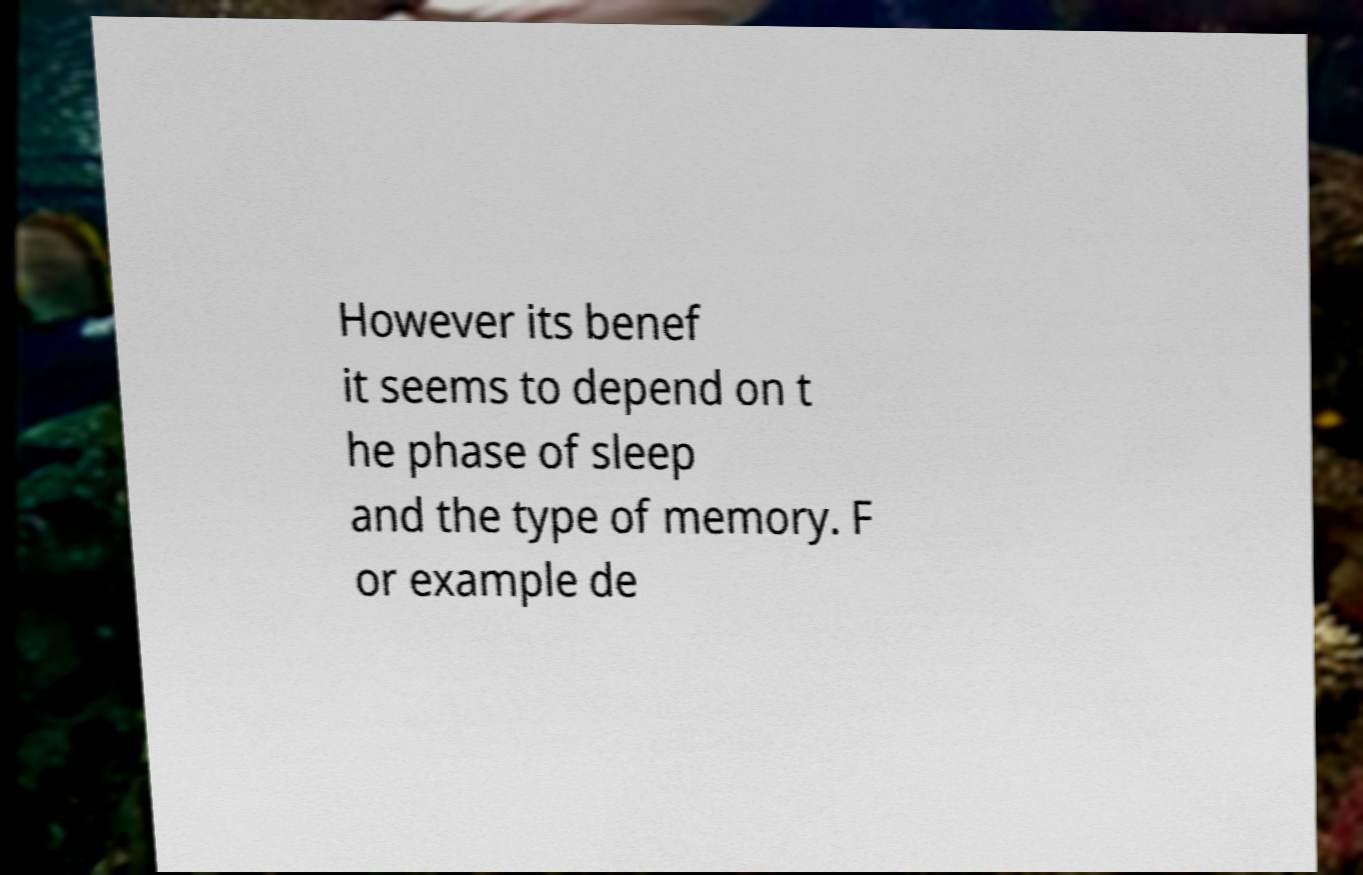Can you read and provide the text displayed in the image?This photo seems to have some interesting text. Can you extract and type it out for me? However its benef it seems to depend on t he phase of sleep and the type of memory. F or example de 